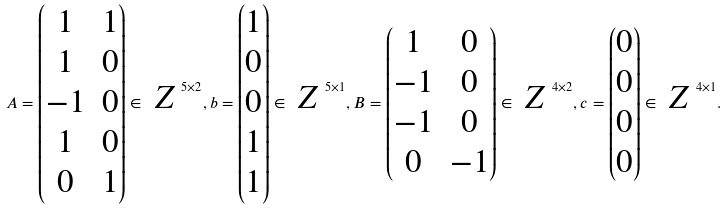Convert formula to latex. <formula><loc_0><loc_0><loc_500><loc_500>A = \begin{pmatrix} 1 & 1 \\ 1 & 0 \\ - 1 & 0 \\ 1 & 0 \\ 0 & 1 \\ \end{pmatrix} \in \emph { Z } ^ { 5 \times 2 } , b = \begin{pmatrix} 1 \\ 0 \\ 0 \\ 1 \\ 1 \end{pmatrix} \in \emph { Z } ^ { 5 \times 1 } , B = \begin{pmatrix} 1 & 0 \\ - 1 & 0 \\ - 1 & 0 \\ 0 & - 1 \end{pmatrix} \in \emph { Z } ^ { 4 \times 2 } , c = \begin{pmatrix} 0 \\ 0 \\ 0 \\ 0 \end{pmatrix} \in \emph { Z } ^ { 4 \times 1 } .</formula> 